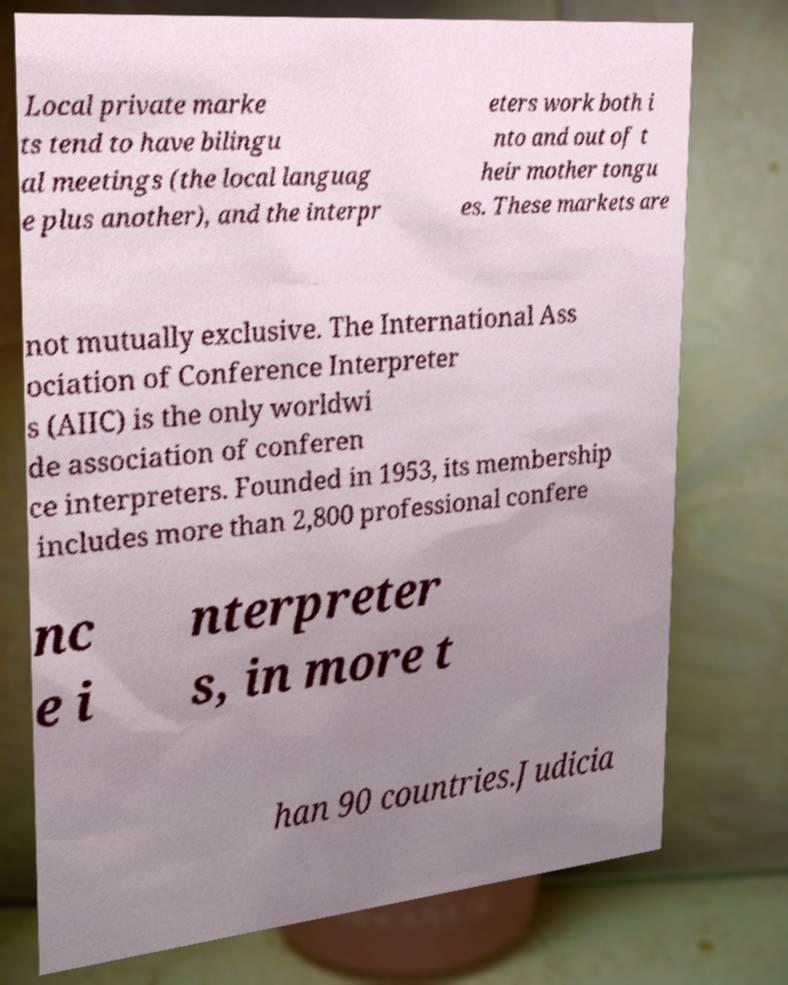Could you assist in decoding the text presented in this image and type it out clearly? Local private marke ts tend to have bilingu al meetings (the local languag e plus another), and the interpr eters work both i nto and out of t heir mother tongu es. These markets are not mutually exclusive. The International Ass ociation of Conference Interpreter s (AIIC) is the only worldwi de association of conferen ce interpreters. Founded in 1953, its membership includes more than 2,800 professional confere nc e i nterpreter s, in more t han 90 countries.Judicia 